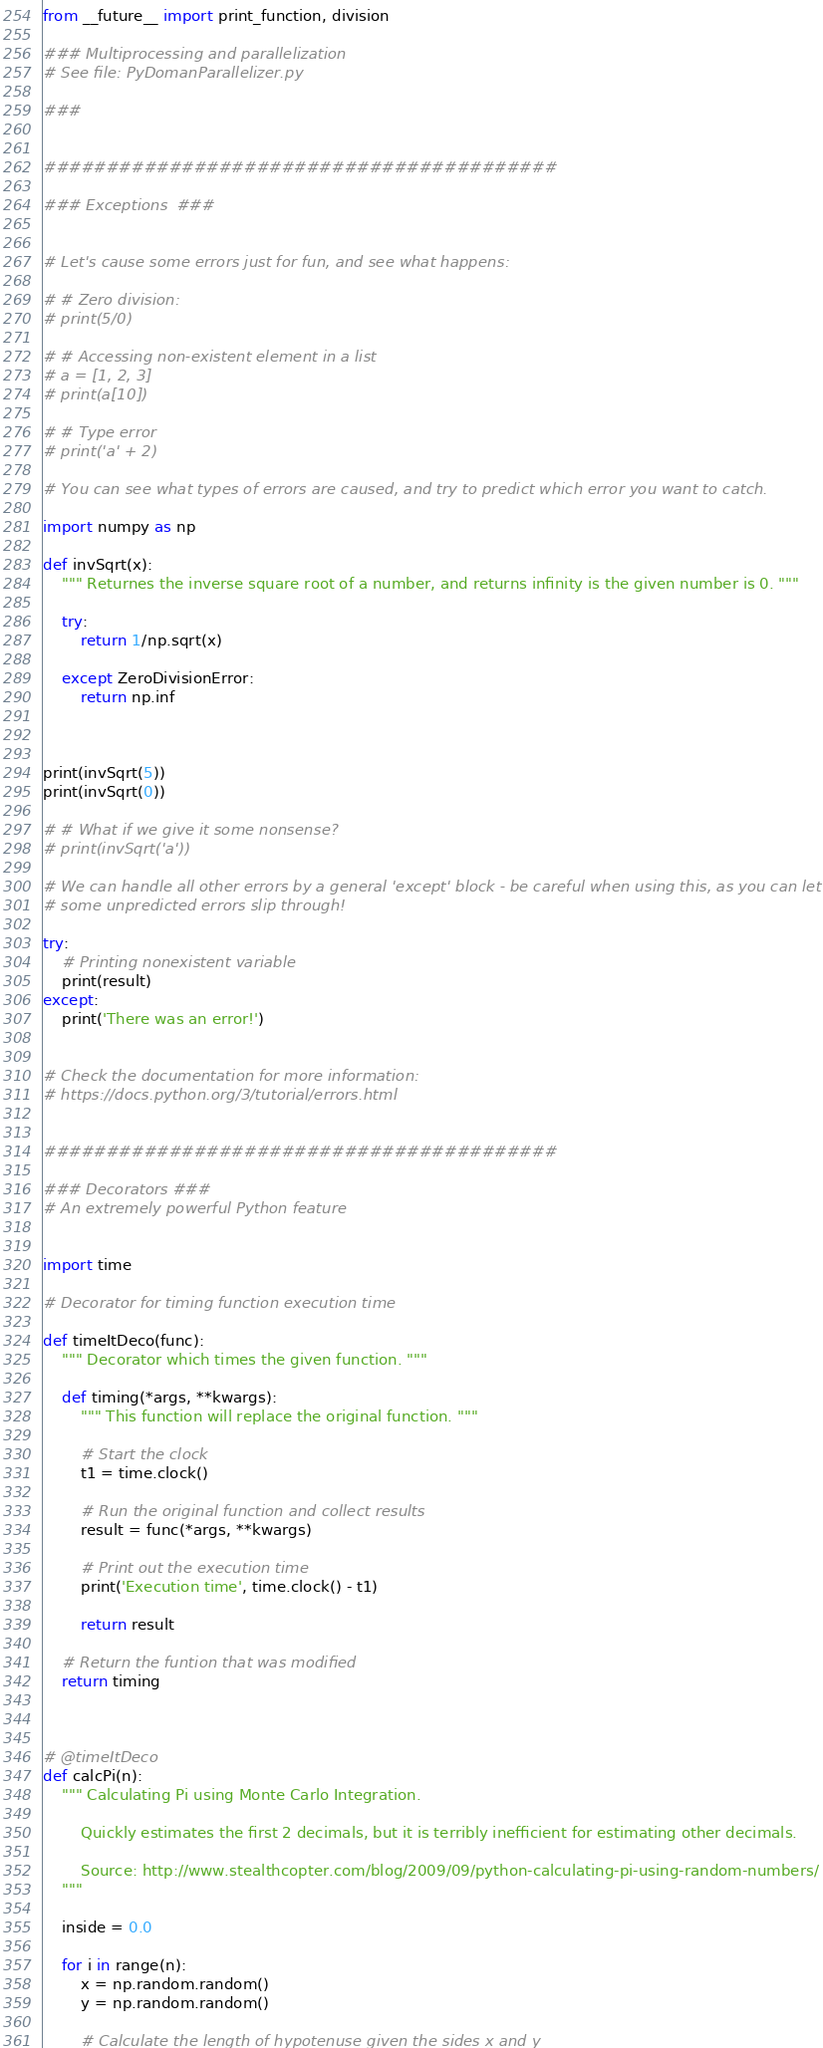Convert code to text. <code><loc_0><loc_0><loc_500><loc_500><_Python_>from __future__ import print_function, division

### Multiprocessing and parallelization
# See file: PyDomanParallelizer.py

###


#########################################

### Exceptions  ###


# Let's cause some errors just for fun, and see what happens:

# # Zero division:
# print(5/0)

# # Accessing non-existent element in a list
# a = [1, 2, 3]
# print(a[10])

# # Type error
# print('a' + 2)

# You can see what types of errors are caused, and try to predict which error you want to catch.

import numpy as np

def invSqrt(x):
    """ Returnes the inverse square root of a number, and returns infinity is the given number is 0. """

    try:
        return 1/np.sqrt(x)

    except ZeroDivisionError:
        return np.inf



print(invSqrt(5))
print(invSqrt(0))

# # What if we give it some nonsense?
# print(invSqrt('a'))

# We can handle all other errors by a general 'except' block - be careful when using this, as you can let
# some unpredicted errors slip through!

try:
    # Printing nonexistent variable
    print(result)
except:
    print('There was an error!')


# Check the documentation for more information:
# https://docs.python.org/3/tutorial/errors.html


#########################################

### Decorators ###
# An extremely powerful Python feature


import time

# Decorator for timing function execution time

def timeItDeco(func):
    """ Decorator which times the given function. """

    def timing(*args, **kwargs):
        """ This function will replace the original function. """

        # Start the clock
        t1 = time.clock()

        # Run the original function and collect results
        result = func(*args, **kwargs)

        # Print out the execution time
        print('Execution time', time.clock() - t1)

        return result

    # Return the funtion that was modified
    return timing



# @timeItDeco
def calcPi(n):
    """ Calculating Pi using Monte Carlo Integration. 
        
        Quickly estimates the first 2 decimals, but it is terribly inefficient for estimating other decimals.

        Source: http://www.stealthcopter.com/blog/2009/09/python-calculating-pi-using-random-numbers/
    """

    inside = 0.0

    for i in range(n):
        x = np.random.random()
        y = np.random.random()

        # Calculate the length of hypotenuse given the sides x and y</code> 